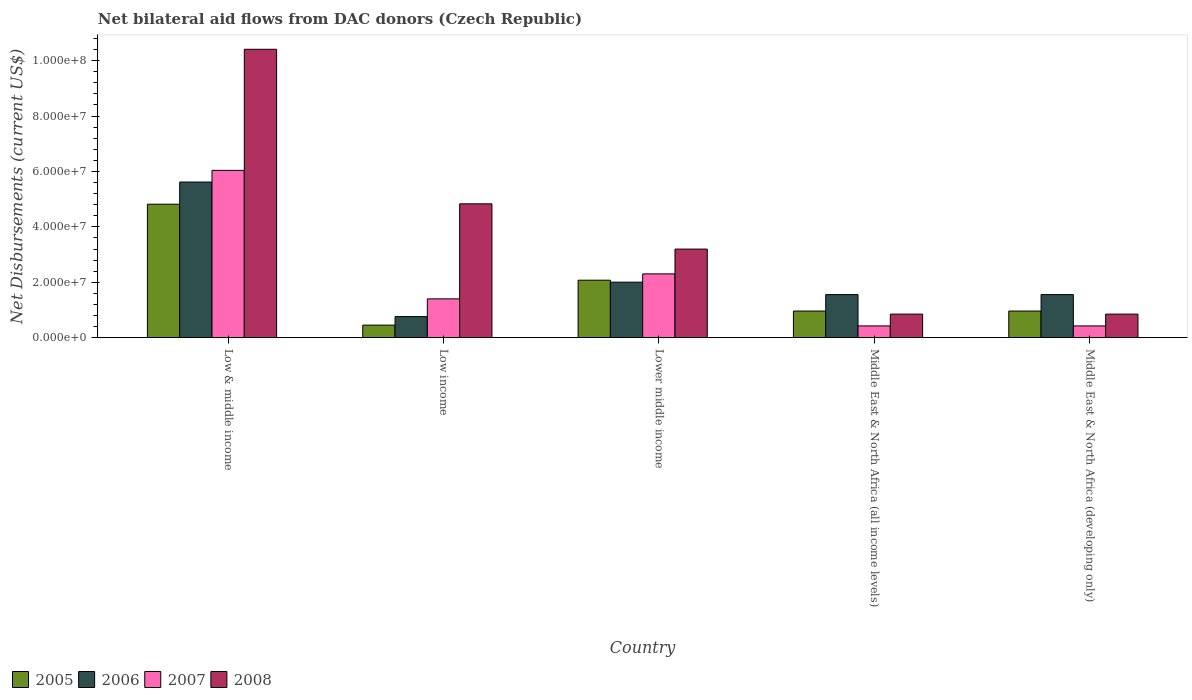How many different coloured bars are there?
Your answer should be compact. 4. Are the number of bars per tick equal to the number of legend labels?
Your answer should be very brief. Yes. Are the number of bars on each tick of the X-axis equal?
Make the answer very short. Yes. What is the label of the 5th group of bars from the left?
Ensure brevity in your answer.  Middle East & North Africa (developing only). In how many cases, is the number of bars for a given country not equal to the number of legend labels?
Make the answer very short. 0. What is the net bilateral aid flows in 2007 in Middle East & North Africa (developing only)?
Ensure brevity in your answer.  4.24e+06. Across all countries, what is the maximum net bilateral aid flows in 2007?
Offer a terse response. 6.04e+07. Across all countries, what is the minimum net bilateral aid flows in 2006?
Your response must be concise. 7.61e+06. In which country was the net bilateral aid flows in 2007 minimum?
Give a very brief answer. Middle East & North Africa (all income levels). What is the total net bilateral aid flows in 2006 in the graph?
Ensure brevity in your answer.  1.15e+08. What is the difference between the net bilateral aid flows in 2006 in Lower middle income and that in Middle East & North Africa (developing only)?
Provide a short and direct response. 4.48e+06. What is the difference between the net bilateral aid flows in 2005 in Low & middle income and the net bilateral aid flows in 2007 in Low income?
Offer a terse response. 3.42e+07. What is the average net bilateral aid flows in 2008 per country?
Offer a very short reply. 4.03e+07. What is the difference between the net bilateral aid flows of/in 2008 and net bilateral aid flows of/in 2007 in Low income?
Ensure brevity in your answer.  3.43e+07. In how many countries, is the net bilateral aid flows in 2005 greater than 100000000 US$?
Provide a short and direct response. 0. What is the ratio of the net bilateral aid flows in 2007 in Lower middle income to that in Middle East & North Africa (all income levels)?
Keep it short and to the point. 5.43. What is the difference between the highest and the second highest net bilateral aid flows in 2008?
Keep it short and to the point. 5.58e+07. What is the difference between the highest and the lowest net bilateral aid flows in 2006?
Make the answer very short. 4.86e+07. Is it the case that in every country, the sum of the net bilateral aid flows in 2008 and net bilateral aid flows in 2006 is greater than the sum of net bilateral aid flows in 2007 and net bilateral aid flows in 2005?
Your response must be concise. No. What does the 4th bar from the left in Middle East & North Africa (developing only) represents?
Provide a succinct answer. 2008. What does the 4th bar from the right in Lower middle income represents?
Provide a succinct answer. 2005. Is it the case that in every country, the sum of the net bilateral aid flows in 2007 and net bilateral aid flows in 2005 is greater than the net bilateral aid flows in 2006?
Provide a succinct answer. No. Are all the bars in the graph horizontal?
Your response must be concise. No. What is the difference between two consecutive major ticks on the Y-axis?
Keep it short and to the point. 2.00e+07. Does the graph contain any zero values?
Your response must be concise. No. Does the graph contain grids?
Your answer should be very brief. No. Where does the legend appear in the graph?
Your answer should be very brief. Bottom left. How are the legend labels stacked?
Offer a very short reply. Horizontal. What is the title of the graph?
Ensure brevity in your answer.  Net bilateral aid flows from DAC donors (Czech Republic). What is the label or title of the Y-axis?
Offer a terse response. Net Disbursements (current US$). What is the Net Disbursements (current US$) in 2005 in Low & middle income?
Ensure brevity in your answer.  4.82e+07. What is the Net Disbursements (current US$) in 2006 in Low & middle income?
Your answer should be compact. 5.62e+07. What is the Net Disbursements (current US$) in 2007 in Low & middle income?
Offer a very short reply. 6.04e+07. What is the Net Disbursements (current US$) of 2008 in Low & middle income?
Offer a very short reply. 1.04e+08. What is the Net Disbursements (current US$) of 2005 in Low income?
Provide a succinct answer. 4.53e+06. What is the Net Disbursements (current US$) in 2006 in Low income?
Make the answer very short. 7.61e+06. What is the Net Disbursements (current US$) in 2007 in Low income?
Your answer should be very brief. 1.40e+07. What is the Net Disbursements (current US$) of 2008 in Low income?
Offer a terse response. 4.83e+07. What is the Net Disbursements (current US$) of 2005 in Lower middle income?
Keep it short and to the point. 2.07e+07. What is the Net Disbursements (current US$) in 2006 in Lower middle income?
Your response must be concise. 2.00e+07. What is the Net Disbursements (current US$) of 2007 in Lower middle income?
Ensure brevity in your answer.  2.30e+07. What is the Net Disbursements (current US$) in 2008 in Lower middle income?
Keep it short and to the point. 3.20e+07. What is the Net Disbursements (current US$) in 2005 in Middle East & North Africa (all income levels)?
Keep it short and to the point. 9.61e+06. What is the Net Disbursements (current US$) in 2006 in Middle East & North Africa (all income levels)?
Your answer should be very brief. 1.56e+07. What is the Net Disbursements (current US$) in 2007 in Middle East & North Africa (all income levels)?
Provide a succinct answer. 4.24e+06. What is the Net Disbursements (current US$) in 2008 in Middle East & North Africa (all income levels)?
Your answer should be very brief. 8.50e+06. What is the Net Disbursements (current US$) of 2005 in Middle East & North Africa (developing only)?
Your answer should be very brief. 9.61e+06. What is the Net Disbursements (current US$) of 2006 in Middle East & North Africa (developing only)?
Your answer should be compact. 1.56e+07. What is the Net Disbursements (current US$) in 2007 in Middle East & North Africa (developing only)?
Keep it short and to the point. 4.24e+06. What is the Net Disbursements (current US$) in 2008 in Middle East & North Africa (developing only)?
Provide a succinct answer. 8.50e+06. Across all countries, what is the maximum Net Disbursements (current US$) of 2005?
Ensure brevity in your answer.  4.82e+07. Across all countries, what is the maximum Net Disbursements (current US$) in 2006?
Offer a terse response. 5.62e+07. Across all countries, what is the maximum Net Disbursements (current US$) of 2007?
Give a very brief answer. 6.04e+07. Across all countries, what is the maximum Net Disbursements (current US$) of 2008?
Offer a very short reply. 1.04e+08. Across all countries, what is the minimum Net Disbursements (current US$) of 2005?
Offer a very short reply. 4.53e+06. Across all countries, what is the minimum Net Disbursements (current US$) of 2006?
Provide a succinct answer. 7.61e+06. Across all countries, what is the minimum Net Disbursements (current US$) in 2007?
Your response must be concise. 4.24e+06. Across all countries, what is the minimum Net Disbursements (current US$) in 2008?
Your answer should be compact. 8.50e+06. What is the total Net Disbursements (current US$) of 2005 in the graph?
Provide a succinct answer. 9.27e+07. What is the total Net Disbursements (current US$) of 2006 in the graph?
Offer a very short reply. 1.15e+08. What is the total Net Disbursements (current US$) of 2007 in the graph?
Offer a terse response. 1.06e+08. What is the total Net Disbursements (current US$) in 2008 in the graph?
Provide a succinct answer. 2.01e+08. What is the difference between the Net Disbursements (current US$) in 2005 in Low & middle income and that in Low income?
Give a very brief answer. 4.36e+07. What is the difference between the Net Disbursements (current US$) of 2006 in Low & middle income and that in Low income?
Give a very brief answer. 4.86e+07. What is the difference between the Net Disbursements (current US$) in 2007 in Low & middle income and that in Low income?
Provide a succinct answer. 4.64e+07. What is the difference between the Net Disbursements (current US$) in 2008 in Low & middle income and that in Low income?
Offer a very short reply. 5.58e+07. What is the difference between the Net Disbursements (current US$) of 2005 in Low & middle income and that in Lower middle income?
Your response must be concise. 2.74e+07. What is the difference between the Net Disbursements (current US$) in 2006 in Low & middle income and that in Lower middle income?
Ensure brevity in your answer.  3.61e+07. What is the difference between the Net Disbursements (current US$) of 2007 in Low & middle income and that in Lower middle income?
Make the answer very short. 3.74e+07. What is the difference between the Net Disbursements (current US$) of 2008 in Low & middle income and that in Lower middle income?
Give a very brief answer. 7.21e+07. What is the difference between the Net Disbursements (current US$) of 2005 in Low & middle income and that in Middle East & North Africa (all income levels)?
Your answer should be very brief. 3.86e+07. What is the difference between the Net Disbursements (current US$) in 2006 in Low & middle income and that in Middle East & North Africa (all income levels)?
Give a very brief answer. 4.06e+07. What is the difference between the Net Disbursements (current US$) in 2007 in Low & middle income and that in Middle East & North Africa (all income levels)?
Keep it short and to the point. 5.61e+07. What is the difference between the Net Disbursements (current US$) in 2008 in Low & middle income and that in Middle East & North Africa (all income levels)?
Provide a short and direct response. 9.56e+07. What is the difference between the Net Disbursements (current US$) of 2005 in Low & middle income and that in Middle East & North Africa (developing only)?
Your answer should be compact. 3.86e+07. What is the difference between the Net Disbursements (current US$) in 2006 in Low & middle income and that in Middle East & North Africa (developing only)?
Ensure brevity in your answer.  4.06e+07. What is the difference between the Net Disbursements (current US$) in 2007 in Low & middle income and that in Middle East & North Africa (developing only)?
Ensure brevity in your answer.  5.61e+07. What is the difference between the Net Disbursements (current US$) of 2008 in Low & middle income and that in Middle East & North Africa (developing only)?
Provide a succinct answer. 9.56e+07. What is the difference between the Net Disbursements (current US$) of 2005 in Low income and that in Lower middle income?
Ensure brevity in your answer.  -1.62e+07. What is the difference between the Net Disbursements (current US$) of 2006 in Low income and that in Lower middle income?
Keep it short and to the point. -1.24e+07. What is the difference between the Net Disbursements (current US$) in 2007 in Low income and that in Lower middle income?
Your answer should be very brief. -9.02e+06. What is the difference between the Net Disbursements (current US$) of 2008 in Low income and that in Lower middle income?
Ensure brevity in your answer.  1.63e+07. What is the difference between the Net Disbursements (current US$) in 2005 in Low income and that in Middle East & North Africa (all income levels)?
Your answer should be compact. -5.08e+06. What is the difference between the Net Disbursements (current US$) of 2006 in Low income and that in Middle East & North Africa (all income levels)?
Offer a terse response. -7.94e+06. What is the difference between the Net Disbursements (current US$) of 2007 in Low income and that in Middle East & North Africa (all income levels)?
Ensure brevity in your answer.  9.76e+06. What is the difference between the Net Disbursements (current US$) of 2008 in Low income and that in Middle East & North Africa (all income levels)?
Make the answer very short. 3.98e+07. What is the difference between the Net Disbursements (current US$) of 2005 in Low income and that in Middle East & North Africa (developing only)?
Provide a succinct answer. -5.08e+06. What is the difference between the Net Disbursements (current US$) in 2006 in Low income and that in Middle East & North Africa (developing only)?
Your answer should be compact. -7.94e+06. What is the difference between the Net Disbursements (current US$) in 2007 in Low income and that in Middle East & North Africa (developing only)?
Offer a very short reply. 9.76e+06. What is the difference between the Net Disbursements (current US$) in 2008 in Low income and that in Middle East & North Africa (developing only)?
Give a very brief answer. 3.98e+07. What is the difference between the Net Disbursements (current US$) of 2005 in Lower middle income and that in Middle East & North Africa (all income levels)?
Make the answer very short. 1.11e+07. What is the difference between the Net Disbursements (current US$) in 2006 in Lower middle income and that in Middle East & North Africa (all income levels)?
Offer a very short reply. 4.48e+06. What is the difference between the Net Disbursements (current US$) of 2007 in Lower middle income and that in Middle East & North Africa (all income levels)?
Your response must be concise. 1.88e+07. What is the difference between the Net Disbursements (current US$) of 2008 in Lower middle income and that in Middle East & North Africa (all income levels)?
Your answer should be very brief. 2.35e+07. What is the difference between the Net Disbursements (current US$) of 2005 in Lower middle income and that in Middle East & North Africa (developing only)?
Your answer should be very brief. 1.11e+07. What is the difference between the Net Disbursements (current US$) of 2006 in Lower middle income and that in Middle East & North Africa (developing only)?
Make the answer very short. 4.48e+06. What is the difference between the Net Disbursements (current US$) in 2007 in Lower middle income and that in Middle East & North Africa (developing only)?
Give a very brief answer. 1.88e+07. What is the difference between the Net Disbursements (current US$) in 2008 in Lower middle income and that in Middle East & North Africa (developing only)?
Offer a terse response. 2.35e+07. What is the difference between the Net Disbursements (current US$) of 2005 in Middle East & North Africa (all income levels) and that in Middle East & North Africa (developing only)?
Offer a terse response. 0. What is the difference between the Net Disbursements (current US$) of 2006 in Middle East & North Africa (all income levels) and that in Middle East & North Africa (developing only)?
Your answer should be compact. 0. What is the difference between the Net Disbursements (current US$) in 2007 in Middle East & North Africa (all income levels) and that in Middle East & North Africa (developing only)?
Keep it short and to the point. 0. What is the difference between the Net Disbursements (current US$) in 2008 in Middle East & North Africa (all income levels) and that in Middle East & North Africa (developing only)?
Ensure brevity in your answer.  0. What is the difference between the Net Disbursements (current US$) in 2005 in Low & middle income and the Net Disbursements (current US$) in 2006 in Low income?
Offer a terse response. 4.06e+07. What is the difference between the Net Disbursements (current US$) of 2005 in Low & middle income and the Net Disbursements (current US$) of 2007 in Low income?
Your answer should be compact. 3.42e+07. What is the difference between the Net Disbursements (current US$) of 2006 in Low & middle income and the Net Disbursements (current US$) of 2007 in Low income?
Your answer should be compact. 4.22e+07. What is the difference between the Net Disbursements (current US$) of 2006 in Low & middle income and the Net Disbursements (current US$) of 2008 in Low income?
Provide a succinct answer. 7.86e+06. What is the difference between the Net Disbursements (current US$) of 2007 in Low & middle income and the Net Disbursements (current US$) of 2008 in Low income?
Provide a short and direct response. 1.21e+07. What is the difference between the Net Disbursements (current US$) in 2005 in Low & middle income and the Net Disbursements (current US$) in 2006 in Lower middle income?
Your answer should be very brief. 2.81e+07. What is the difference between the Net Disbursements (current US$) of 2005 in Low & middle income and the Net Disbursements (current US$) of 2007 in Lower middle income?
Your answer should be very brief. 2.52e+07. What is the difference between the Net Disbursements (current US$) in 2005 in Low & middle income and the Net Disbursements (current US$) in 2008 in Lower middle income?
Your answer should be compact. 1.62e+07. What is the difference between the Net Disbursements (current US$) in 2006 in Low & middle income and the Net Disbursements (current US$) in 2007 in Lower middle income?
Keep it short and to the point. 3.32e+07. What is the difference between the Net Disbursements (current US$) in 2006 in Low & middle income and the Net Disbursements (current US$) in 2008 in Lower middle income?
Provide a short and direct response. 2.42e+07. What is the difference between the Net Disbursements (current US$) in 2007 in Low & middle income and the Net Disbursements (current US$) in 2008 in Lower middle income?
Give a very brief answer. 2.84e+07. What is the difference between the Net Disbursements (current US$) of 2005 in Low & middle income and the Net Disbursements (current US$) of 2006 in Middle East & North Africa (all income levels)?
Provide a short and direct response. 3.26e+07. What is the difference between the Net Disbursements (current US$) of 2005 in Low & middle income and the Net Disbursements (current US$) of 2007 in Middle East & North Africa (all income levels)?
Your answer should be compact. 4.39e+07. What is the difference between the Net Disbursements (current US$) in 2005 in Low & middle income and the Net Disbursements (current US$) in 2008 in Middle East & North Africa (all income levels)?
Provide a short and direct response. 3.97e+07. What is the difference between the Net Disbursements (current US$) in 2006 in Low & middle income and the Net Disbursements (current US$) in 2007 in Middle East & North Africa (all income levels)?
Make the answer very short. 5.19e+07. What is the difference between the Net Disbursements (current US$) of 2006 in Low & middle income and the Net Disbursements (current US$) of 2008 in Middle East & North Africa (all income levels)?
Offer a terse response. 4.77e+07. What is the difference between the Net Disbursements (current US$) of 2007 in Low & middle income and the Net Disbursements (current US$) of 2008 in Middle East & North Africa (all income levels)?
Provide a succinct answer. 5.19e+07. What is the difference between the Net Disbursements (current US$) of 2005 in Low & middle income and the Net Disbursements (current US$) of 2006 in Middle East & North Africa (developing only)?
Give a very brief answer. 3.26e+07. What is the difference between the Net Disbursements (current US$) in 2005 in Low & middle income and the Net Disbursements (current US$) in 2007 in Middle East & North Africa (developing only)?
Ensure brevity in your answer.  4.39e+07. What is the difference between the Net Disbursements (current US$) in 2005 in Low & middle income and the Net Disbursements (current US$) in 2008 in Middle East & North Africa (developing only)?
Give a very brief answer. 3.97e+07. What is the difference between the Net Disbursements (current US$) in 2006 in Low & middle income and the Net Disbursements (current US$) in 2007 in Middle East & North Africa (developing only)?
Your answer should be very brief. 5.19e+07. What is the difference between the Net Disbursements (current US$) of 2006 in Low & middle income and the Net Disbursements (current US$) of 2008 in Middle East & North Africa (developing only)?
Provide a short and direct response. 4.77e+07. What is the difference between the Net Disbursements (current US$) in 2007 in Low & middle income and the Net Disbursements (current US$) in 2008 in Middle East & North Africa (developing only)?
Ensure brevity in your answer.  5.19e+07. What is the difference between the Net Disbursements (current US$) of 2005 in Low income and the Net Disbursements (current US$) of 2006 in Lower middle income?
Keep it short and to the point. -1.55e+07. What is the difference between the Net Disbursements (current US$) in 2005 in Low income and the Net Disbursements (current US$) in 2007 in Lower middle income?
Give a very brief answer. -1.85e+07. What is the difference between the Net Disbursements (current US$) of 2005 in Low income and the Net Disbursements (current US$) of 2008 in Lower middle income?
Provide a short and direct response. -2.74e+07. What is the difference between the Net Disbursements (current US$) of 2006 in Low income and the Net Disbursements (current US$) of 2007 in Lower middle income?
Your response must be concise. -1.54e+07. What is the difference between the Net Disbursements (current US$) of 2006 in Low income and the Net Disbursements (current US$) of 2008 in Lower middle income?
Your response must be concise. -2.44e+07. What is the difference between the Net Disbursements (current US$) in 2007 in Low income and the Net Disbursements (current US$) in 2008 in Lower middle income?
Provide a succinct answer. -1.80e+07. What is the difference between the Net Disbursements (current US$) in 2005 in Low income and the Net Disbursements (current US$) in 2006 in Middle East & North Africa (all income levels)?
Make the answer very short. -1.10e+07. What is the difference between the Net Disbursements (current US$) of 2005 in Low income and the Net Disbursements (current US$) of 2007 in Middle East & North Africa (all income levels)?
Keep it short and to the point. 2.90e+05. What is the difference between the Net Disbursements (current US$) of 2005 in Low income and the Net Disbursements (current US$) of 2008 in Middle East & North Africa (all income levels)?
Give a very brief answer. -3.97e+06. What is the difference between the Net Disbursements (current US$) of 2006 in Low income and the Net Disbursements (current US$) of 2007 in Middle East & North Africa (all income levels)?
Your response must be concise. 3.37e+06. What is the difference between the Net Disbursements (current US$) in 2006 in Low income and the Net Disbursements (current US$) in 2008 in Middle East & North Africa (all income levels)?
Provide a succinct answer. -8.90e+05. What is the difference between the Net Disbursements (current US$) in 2007 in Low income and the Net Disbursements (current US$) in 2008 in Middle East & North Africa (all income levels)?
Offer a terse response. 5.50e+06. What is the difference between the Net Disbursements (current US$) in 2005 in Low income and the Net Disbursements (current US$) in 2006 in Middle East & North Africa (developing only)?
Ensure brevity in your answer.  -1.10e+07. What is the difference between the Net Disbursements (current US$) of 2005 in Low income and the Net Disbursements (current US$) of 2008 in Middle East & North Africa (developing only)?
Provide a succinct answer. -3.97e+06. What is the difference between the Net Disbursements (current US$) of 2006 in Low income and the Net Disbursements (current US$) of 2007 in Middle East & North Africa (developing only)?
Make the answer very short. 3.37e+06. What is the difference between the Net Disbursements (current US$) in 2006 in Low income and the Net Disbursements (current US$) in 2008 in Middle East & North Africa (developing only)?
Keep it short and to the point. -8.90e+05. What is the difference between the Net Disbursements (current US$) of 2007 in Low income and the Net Disbursements (current US$) of 2008 in Middle East & North Africa (developing only)?
Your answer should be compact. 5.50e+06. What is the difference between the Net Disbursements (current US$) of 2005 in Lower middle income and the Net Disbursements (current US$) of 2006 in Middle East & North Africa (all income levels)?
Provide a succinct answer. 5.19e+06. What is the difference between the Net Disbursements (current US$) of 2005 in Lower middle income and the Net Disbursements (current US$) of 2007 in Middle East & North Africa (all income levels)?
Offer a very short reply. 1.65e+07. What is the difference between the Net Disbursements (current US$) of 2005 in Lower middle income and the Net Disbursements (current US$) of 2008 in Middle East & North Africa (all income levels)?
Provide a short and direct response. 1.22e+07. What is the difference between the Net Disbursements (current US$) of 2006 in Lower middle income and the Net Disbursements (current US$) of 2007 in Middle East & North Africa (all income levels)?
Keep it short and to the point. 1.58e+07. What is the difference between the Net Disbursements (current US$) in 2006 in Lower middle income and the Net Disbursements (current US$) in 2008 in Middle East & North Africa (all income levels)?
Your answer should be very brief. 1.15e+07. What is the difference between the Net Disbursements (current US$) in 2007 in Lower middle income and the Net Disbursements (current US$) in 2008 in Middle East & North Africa (all income levels)?
Provide a succinct answer. 1.45e+07. What is the difference between the Net Disbursements (current US$) of 2005 in Lower middle income and the Net Disbursements (current US$) of 2006 in Middle East & North Africa (developing only)?
Make the answer very short. 5.19e+06. What is the difference between the Net Disbursements (current US$) in 2005 in Lower middle income and the Net Disbursements (current US$) in 2007 in Middle East & North Africa (developing only)?
Offer a terse response. 1.65e+07. What is the difference between the Net Disbursements (current US$) of 2005 in Lower middle income and the Net Disbursements (current US$) of 2008 in Middle East & North Africa (developing only)?
Offer a terse response. 1.22e+07. What is the difference between the Net Disbursements (current US$) of 2006 in Lower middle income and the Net Disbursements (current US$) of 2007 in Middle East & North Africa (developing only)?
Offer a very short reply. 1.58e+07. What is the difference between the Net Disbursements (current US$) in 2006 in Lower middle income and the Net Disbursements (current US$) in 2008 in Middle East & North Africa (developing only)?
Make the answer very short. 1.15e+07. What is the difference between the Net Disbursements (current US$) of 2007 in Lower middle income and the Net Disbursements (current US$) of 2008 in Middle East & North Africa (developing only)?
Offer a terse response. 1.45e+07. What is the difference between the Net Disbursements (current US$) of 2005 in Middle East & North Africa (all income levels) and the Net Disbursements (current US$) of 2006 in Middle East & North Africa (developing only)?
Offer a terse response. -5.94e+06. What is the difference between the Net Disbursements (current US$) of 2005 in Middle East & North Africa (all income levels) and the Net Disbursements (current US$) of 2007 in Middle East & North Africa (developing only)?
Provide a succinct answer. 5.37e+06. What is the difference between the Net Disbursements (current US$) in 2005 in Middle East & North Africa (all income levels) and the Net Disbursements (current US$) in 2008 in Middle East & North Africa (developing only)?
Offer a terse response. 1.11e+06. What is the difference between the Net Disbursements (current US$) in 2006 in Middle East & North Africa (all income levels) and the Net Disbursements (current US$) in 2007 in Middle East & North Africa (developing only)?
Your answer should be very brief. 1.13e+07. What is the difference between the Net Disbursements (current US$) of 2006 in Middle East & North Africa (all income levels) and the Net Disbursements (current US$) of 2008 in Middle East & North Africa (developing only)?
Make the answer very short. 7.05e+06. What is the difference between the Net Disbursements (current US$) of 2007 in Middle East & North Africa (all income levels) and the Net Disbursements (current US$) of 2008 in Middle East & North Africa (developing only)?
Keep it short and to the point. -4.26e+06. What is the average Net Disbursements (current US$) in 2005 per country?
Keep it short and to the point. 1.85e+07. What is the average Net Disbursements (current US$) in 2006 per country?
Offer a very short reply. 2.30e+07. What is the average Net Disbursements (current US$) of 2007 per country?
Your answer should be very brief. 2.12e+07. What is the average Net Disbursements (current US$) of 2008 per country?
Offer a very short reply. 4.03e+07. What is the difference between the Net Disbursements (current US$) of 2005 and Net Disbursements (current US$) of 2006 in Low & middle income?
Your answer should be very brief. -8.00e+06. What is the difference between the Net Disbursements (current US$) of 2005 and Net Disbursements (current US$) of 2007 in Low & middle income?
Your response must be concise. -1.22e+07. What is the difference between the Net Disbursements (current US$) in 2005 and Net Disbursements (current US$) in 2008 in Low & middle income?
Make the answer very short. -5.59e+07. What is the difference between the Net Disbursements (current US$) of 2006 and Net Disbursements (current US$) of 2007 in Low & middle income?
Ensure brevity in your answer.  -4.21e+06. What is the difference between the Net Disbursements (current US$) of 2006 and Net Disbursements (current US$) of 2008 in Low & middle income?
Keep it short and to the point. -4.79e+07. What is the difference between the Net Disbursements (current US$) in 2007 and Net Disbursements (current US$) in 2008 in Low & middle income?
Ensure brevity in your answer.  -4.37e+07. What is the difference between the Net Disbursements (current US$) of 2005 and Net Disbursements (current US$) of 2006 in Low income?
Offer a terse response. -3.08e+06. What is the difference between the Net Disbursements (current US$) in 2005 and Net Disbursements (current US$) in 2007 in Low income?
Ensure brevity in your answer.  -9.47e+06. What is the difference between the Net Disbursements (current US$) in 2005 and Net Disbursements (current US$) in 2008 in Low income?
Your response must be concise. -4.38e+07. What is the difference between the Net Disbursements (current US$) in 2006 and Net Disbursements (current US$) in 2007 in Low income?
Offer a terse response. -6.39e+06. What is the difference between the Net Disbursements (current US$) of 2006 and Net Disbursements (current US$) of 2008 in Low income?
Ensure brevity in your answer.  -4.07e+07. What is the difference between the Net Disbursements (current US$) of 2007 and Net Disbursements (current US$) of 2008 in Low income?
Give a very brief answer. -3.43e+07. What is the difference between the Net Disbursements (current US$) in 2005 and Net Disbursements (current US$) in 2006 in Lower middle income?
Offer a very short reply. 7.10e+05. What is the difference between the Net Disbursements (current US$) in 2005 and Net Disbursements (current US$) in 2007 in Lower middle income?
Provide a succinct answer. -2.28e+06. What is the difference between the Net Disbursements (current US$) of 2005 and Net Disbursements (current US$) of 2008 in Lower middle income?
Your answer should be compact. -1.12e+07. What is the difference between the Net Disbursements (current US$) of 2006 and Net Disbursements (current US$) of 2007 in Lower middle income?
Make the answer very short. -2.99e+06. What is the difference between the Net Disbursements (current US$) of 2006 and Net Disbursements (current US$) of 2008 in Lower middle income?
Provide a succinct answer. -1.19e+07. What is the difference between the Net Disbursements (current US$) in 2007 and Net Disbursements (current US$) in 2008 in Lower middle income?
Offer a terse response. -8.95e+06. What is the difference between the Net Disbursements (current US$) of 2005 and Net Disbursements (current US$) of 2006 in Middle East & North Africa (all income levels)?
Offer a terse response. -5.94e+06. What is the difference between the Net Disbursements (current US$) of 2005 and Net Disbursements (current US$) of 2007 in Middle East & North Africa (all income levels)?
Give a very brief answer. 5.37e+06. What is the difference between the Net Disbursements (current US$) of 2005 and Net Disbursements (current US$) of 2008 in Middle East & North Africa (all income levels)?
Provide a succinct answer. 1.11e+06. What is the difference between the Net Disbursements (current US$) of 2006 and Net Disbursements (current US$) of 2007 in Middle East & North Africa (all income levels)?
Provide a succinct answer. 1.13e+07. What is the difference between the Net Disbursements (current US$) of 2006 and Net Disbursements (current US$) of 2008 in Middle East & North Africa (all income levels)?
Provide a succinct answer. 7.05e+06. What is the difference between the Net Disbursements (current US$) of 2007 and Net Disbursements (current US$) of 2008 in Middle East & North Africa (all income levels)?
Offer a very short reply. -4.26e+06. What is the difference between the Net Disbursements (current US$) in 2005 and Net Disbursements (current US$) in 2006 in Middle East & North Africa (developing only)?
Provide a succinct answer. -5.94e+06. What is the difference between the Net Disbursements (current US$) in 2005 and Net Disbursements (current US$) in 2007 in Middle East & North Africa (developing only)?
Give a very brief answer. 5.37e+06. What is the difference between the Net Disbursements (current US$) in 2005 and Net Disbursements (current US$) in 2008 in Middle East & North Africa (developing only)?
Your answer should be very brief. 1.11e+06. What is the difference between the Net Disbursements (current US$) in 2006 and Net Disbursements (current US$) in 2007 in Middle East & North Africa (developing only)?
Provide a succinct answer. 1.13e+07. What is the difference between the Net Disbursements (current US$) in 2006 and Net Disbursements (current US$) in 2008 in Middle East & North Africa (developing only)?
Offer a very short reply. 7.05e+06. What is the difference between the Net Disbursements (current US$) of 2007 and Net Disbursements (current US$) of 2008 in Middle East & North Africa (developing only)?
Your response must be concise. -4.26e+06. What is the ratio of the Net Disbursements (current US$) in 2005 in Low & middle income to that in Low income?
Your response must be concise. 10.63. What is the ratio of the Net Disbursements (current US$) in 2006 in Low & middle income to that in Low income?
Offer a terse response. 7.38. What is the ratio of the Net Disbursements (current US$) of 2007 in Low & middle income to that in Low income?
Your response must be concise. 4.31. What is the ratio of the Net Disbursements (current US$) of 2008 in Low & middle income to that in Low income?
Offer a very short reply. 2.15. What is the ratio of the Net Disbursements (current US$) in 2005 in Low & middle income to that in Lower middle income?
Ensure brevity in your answer.  2.32. What is the ratio of the Net Disbursements (current US$) in 2006 in Low & middle income to that in Lower middle income?
Provide a succinct answer. 2.8. What is the ratio of the Net Disbursements (current US$) of 2007 in Low & middle income to that in Lower middle income?
Make the answer very short. 2.62. What is the ratio of the Net Disbursements (current US$) of 2008 in Low & middle income to that in Lower middle income?
Your response must be concise. 3.26. What is the ratio of the Net Disbursements (current US$) in 2005 in Low & middle income to that in Middle East & North Africa (all income levels)?
Your response must be concise. 5.01. What is the ratio of the Net Disbursements (current US$) of 2006 in Low & middle income to that in Middle East & North Africa (all income levels)?
Your answer should be very brief. 3.61. What is the ratio of the Net Disbursements (current US$) of 2007 in Low & middle income to that in Middle East & North Africa (all income levels)?
Keep it short and to the point. 14.24. What is the ratio of the Net Disbursements (current US$) in 2008 in Low & middle income to that in Middle East & North Africa (all income levels)?
Offer a terse response. 12.24. What is the ratio of the Net Disbursements (current US$) in 2005 in Low & middle income to that in Middle East & North Africa (developing only)?
Make the answer very short. 5.01. What is the ratio of the Net Disbursements (current US$) of 2006 in Low & middle income to that in Middle East & North Africa (developing only)?
Offer a very short reply. 3.61. What is the ratio of the Net Disbursements (current US$) in 2007 in Low & middle income to that in Middle East & North Africa (developing only)?
Make the answer very short. 14.24. What is the ratio of the Net Disbursements (current US$) in 2008 in Low & middle income to that in Middle East & North Africa (developing only)?
Offer a very short reply. 12.24. What is the ratio of the Net Disbursements (current US$) in 2005 in Low income to that in Lower middle income?
Give a very brief answer. 0.22. What is the ratio of the Net Disbursements (current US$) of 2006 in Low income to that in Lower middle income?
Your answer should be compact. 0.38. What is the ratio of the Net Disbursements (current US$) in 2007 in Low income to that in Lower middle income?
Give a very brief answer. 0.61. What is the ratio of the Net Disbursements (current US$) of 2008 in Low income to that in Lower middle income?
Keep it short and to the point. 1.51. What is the ratio of the Net Disbursements (current US$) in 2005 in Low income to that in Middle East & North Africa (all income levels)?
Ensure brevity in your answer.  0.47. What is the ratio of the Net Disbursements (current US$) of 2006 in Low income to that in Middle East & North Africa (all income levels)?
Offer a very short reply. 0.49. What is the ratio of the Net Disbursements (current US$) in 2007 in Low income to that in Middle East & North Africa (all income levels)?
Provide a succinct answer. 3.3. What is the ratio of the Net Disbursements (current US$) of 2008 in Low income to that in Middle East & North Africa (all income levels)?
Your answer should be very brief. 5.68. What is the ratio of the Net Disbursements (current US$) of 2005 in Low income to that in Middle East & North Africa (developing only)?
Make the answer very short. 0.47. What is the ratio of the Net Disbursements (current US$) of 2006 in Low income to that in Middle East & North Africa (developing only)?
Your response must be concise. 0.49. What is the ratio of the Net Disbursements (current US$) of 2007 in Low income to that in Middle East & North Africa (developing only)?
Give a very brief answer. 3.3. What is the ratio of the Net Disbursements (current US$) in 2008 in Low income to that in Middle East & North Africa (developing only)?
Offer a very short reply. 5.68. What is the ratio of the Net Disbursements (current US$) of 2005 in Lower middle income to that in Middle East & North Africa (all income levels)?
Provide a succinct answer. 2.16. What is the ratio of the Net Disbursements (current US$) in 2006 in Lower middle income to that in Middle East & North Africa (all income levels)?
Make the answer very short. 1.29. What is the ratio of the Net Disbursements (current US$) of 2007 in Lower middle income to that in Middle East & North Africa (all income levels)?
Provide a succinct answer. 5.43. What is the ratio of the Net Disbursements (current US$) of 2008 in Lower middle income to that in Middle East & North Africa (all income levels)?
Give a very brief answer. 3.76. What is the ratio of the Net Disbursements (current US$) of 2005 in Lower middle income to that in Middle East & North Africa (developing only)?
Ensure brevity in your answer.  2.16. What is the ratio of the Net Disbursements (current US$) in 2006 in Lower middle income to that in Middle East & North Africa (developing only)?
Your answer should be very brief. 1.29. What is the ratio of the Net Disbursements (current US$) in 2007 in Lower middle income to that in Middle East & North Africa (developing only)?
Your answer should be very brief. 5.43. What is the ratio of the Net Disbursements (current US$) in 2008 in Lower middle income to that in Middle East & North Africa (developing only)?
Offer a very short reply. 3.76. What is the ratio of the Net Disbursements (current US$) in 2005 in Middle East & North Africa (all income levels) to that in Middle East & North Africa (developing only)?
Provide a succinct answer. 1. What is the ratio of the Net Disbursements (current US$) of 2006 in Middle East & North Africa (all income levels) to that in Middle East & North Africa (developing only)?
Give a very brief answer. 1. What is the ratio of the Net Disbursements (current US$) in 2007 in Middle East & North Africa (all income levels) to that in Middle East & North Africa (developing only)?
Offer a terse response. 1. What is the difference between the highest and the second highest Net Disbursements (current US$) of 2005?
Provide a succinct answer. 2.74e+07. What is the difference between the highest and the second highest Net Disbursements (current US$) of 2006?
Ensure brevity in your answer.  3.61e+07. What is the difference between the highest and the second highest Net Disbursements (current US$) of 2007?
Your answer should be very brief. 3.74e+07. What is the difference between the highest and the second highest Net Disbursements (current US$) in 2008?
Your answer should be very brief. 5.58e+07. What is the difference between the highest and the lowest Net Disbursements (current US$) of 2005?
Offer a very short reply. 4.36e+07. What is the difference between the highest and the lowest Net Disbursements (current US$) in 2006?
Your answer should be very brief. 4.86e+07. What is the difference between the highest and the lowest Net Disbursements (current US$) of 2007?
Offer a very short reply. 5.61e+07. What is the difference between the highest and the lowest Net Disbursements (current US$) in 2008?
Your answer should be very brief. 9.56e+07. 